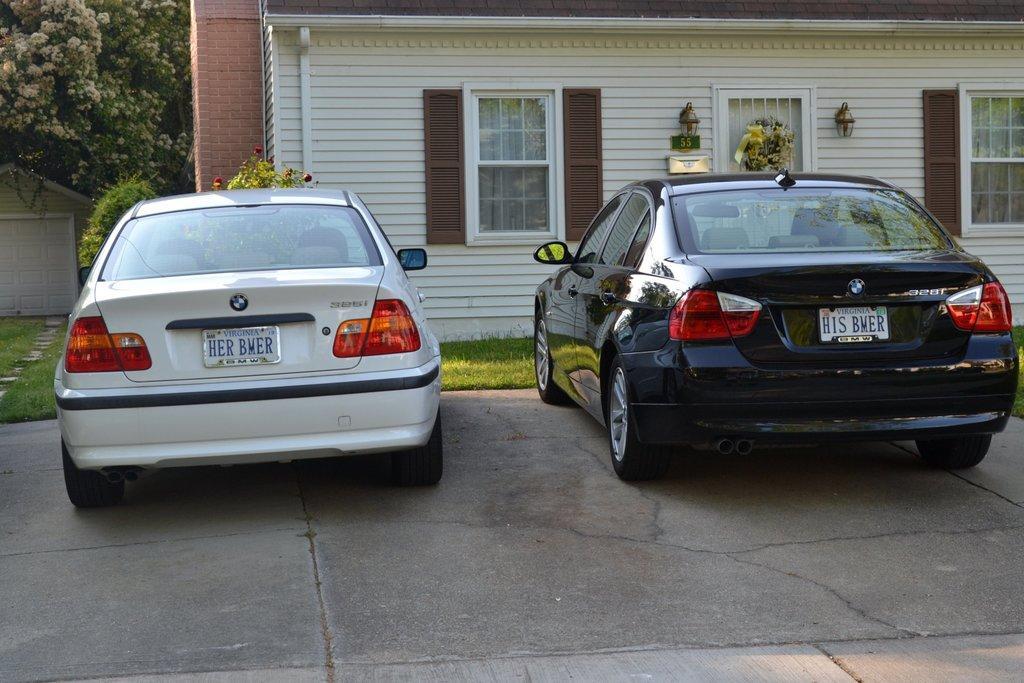Please provide a concise description of this image. In the image we can see two vehicles of different colors and here we can see the number plate of the vehicle. Here we can see the road, grass, house and windows of the house. Here we can see plants and trees. 